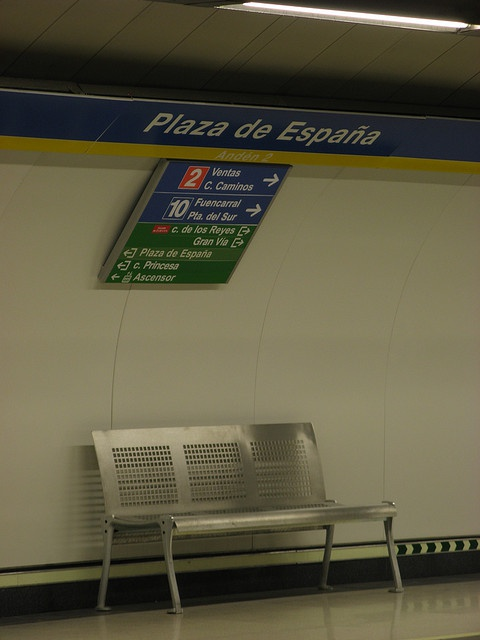Describe the objects in this image and their specific colors. I can see a bench in black, gray, and darkgreen tones in this image. 